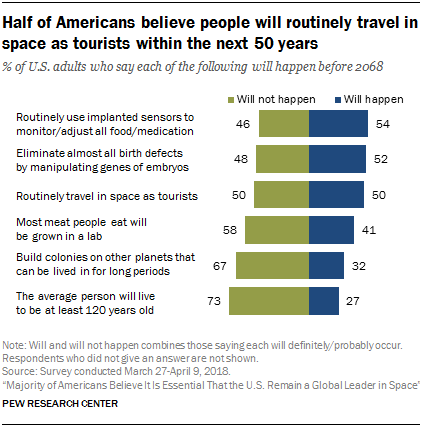List a handful of essential elements in this visual. The topmost green bar is not the smallest green bar. The median of green bars and blue bars is not equal. 